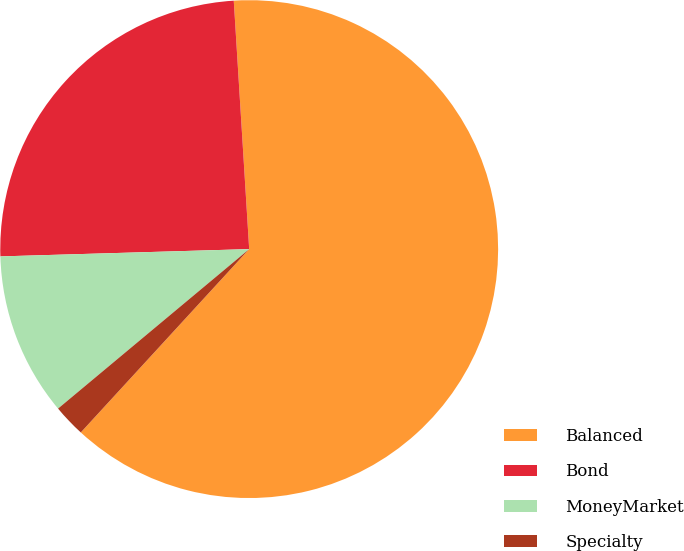Convert chart. <chart><loc_0><loc_0><loc_500><loc_500><pie_chart><fcel>Balanced<fcel>Bond<fcel>MoneyMarket<fcel>Specialty<nl><fcel>62.81%<fcel>24.48%<fcel>10.6%<fcel>2.11%<nl></chart> 